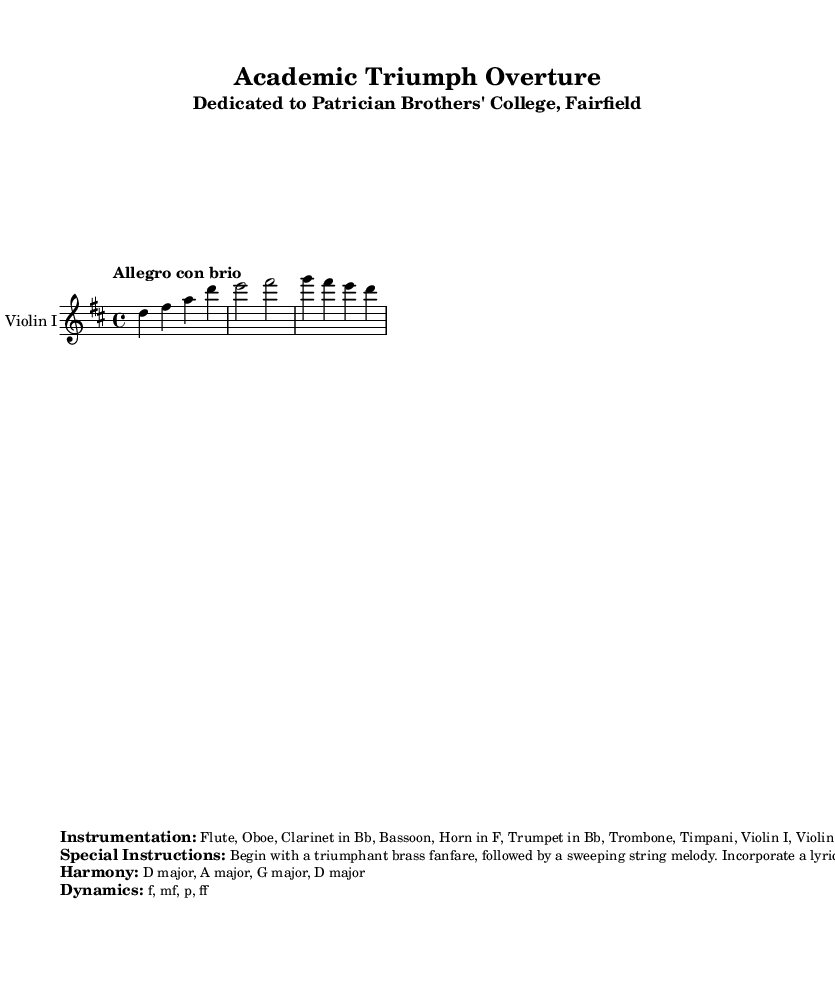What is the key signature of this music? The key signature indicated is D major, which has two sharps: F# and C#. This can be confirmed by looking at the key indication at the beginning of the score.
Answer: D major What is the time signature of this piece? The time signature shown is 4/4, meaning there are four beats per measure, and the quarter note gets one beat. This is typically found at the beginning of the score before the key signature.
Answer: 4/4 What is the tempo marking for this score? The tempo marking is "Allegro con brio," which signifies a fast tempo with vigor. This marking is found at the beginning of the score, indicating how the piece should be played.
Answer: Allegro con brio How many bars are present in the provided violin part? The violin part has four bars (or measures) based on the notation provided in the score. You can count the vertical bar lines that separate the measures to determine this.
Answer: 4 What instruments are included in the instrumentation? The provided instrumentation includes Flute, Oboe, Clarinet in Bb, Bassoon, Horn in F, Trumpet in Bb, Trombone, Timpani, Violin I, Violin II, Viola, Cello, and Double Bass. This is specified in the markup section that details instrumentation.
Answer: Flute, Oboe, Clarinet in Bb, Bassoon, Horn in F, Trumpet in Bb, Trombone, Timpani, Violin I, Violin II, Viola, Cello, Double Bass What dynamics are outlined in the composition? The dynamics indicated are f (forte), mf (mezzo forte), p (piano), and ff (fortissimo). These dynamics suggest varying levels of loudness throughout the piece and are listed in the markup section of the score.
Answer: f, mf, p, ff What musical phrase is represented in the lyrical woodwind section? The lyrical woodwind section symbolizes the journey of learning, as specifically mentioned in the special instructions. This reflects the thematic material of the composition and its significance.
Answer: Journey of learning 